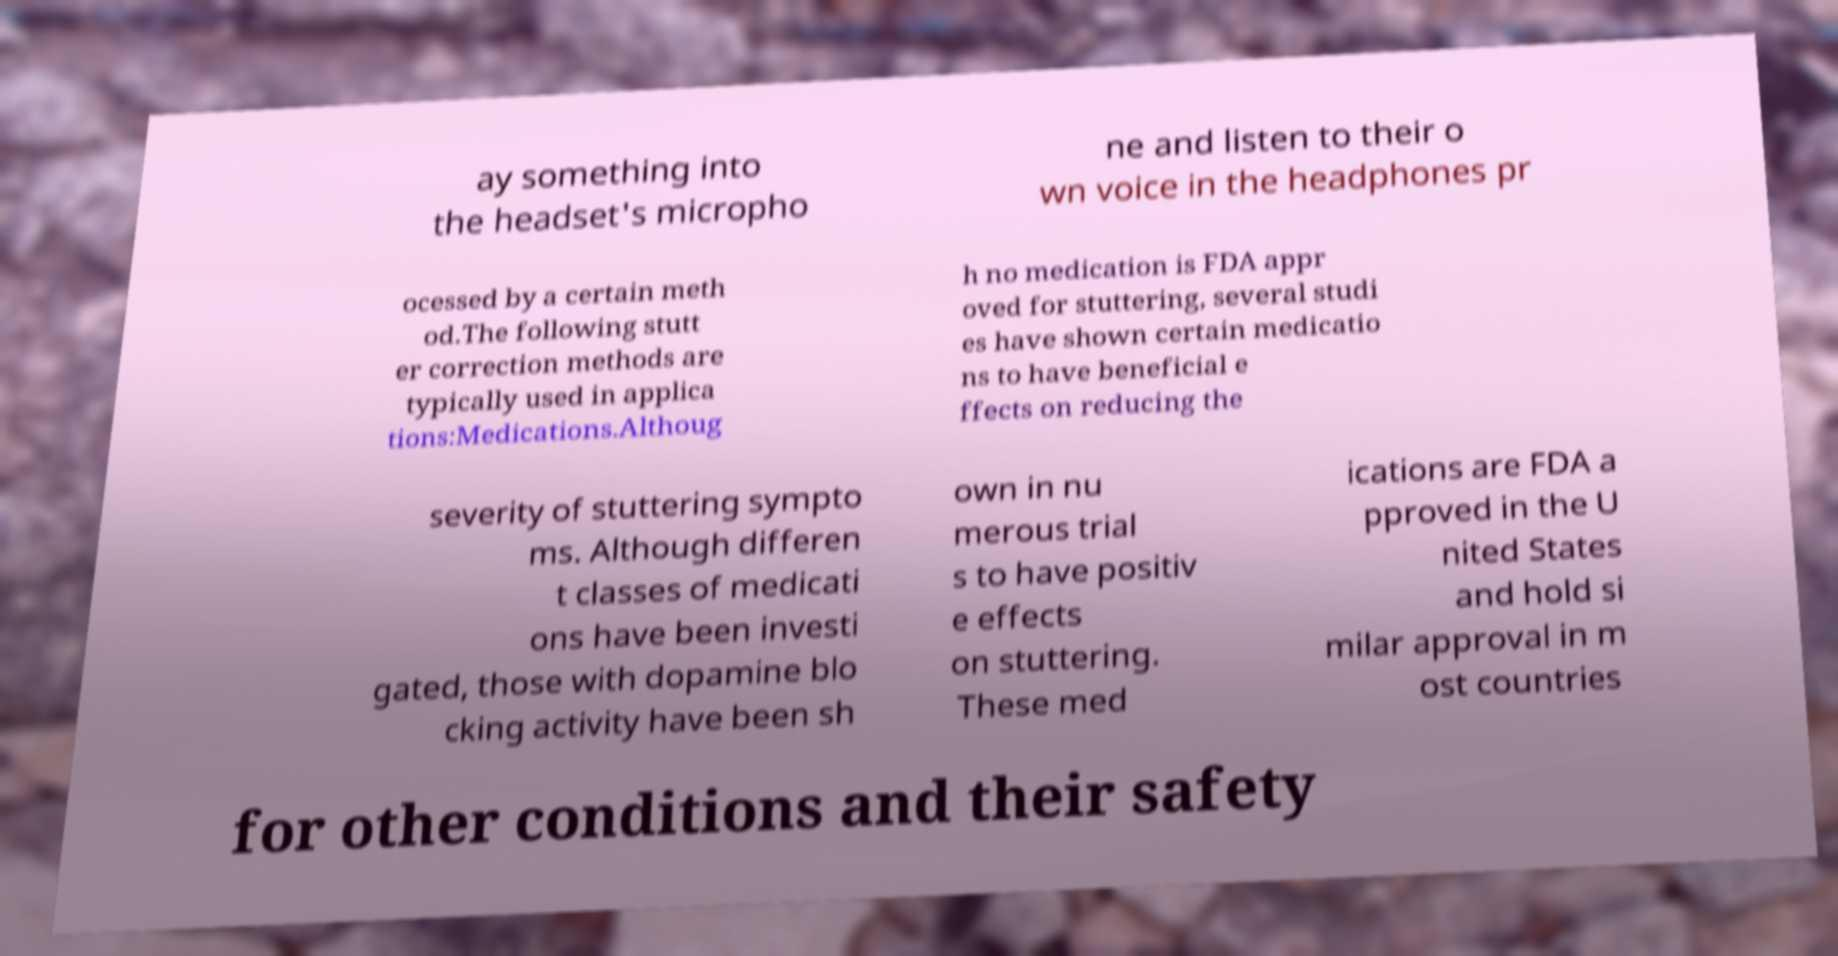What messages or text are displayed in this image? I need them in a readable, typed format. ay something into the headset's micropho ne and listen to their o wn voice in the headphones pr ocessed by a certain meth od.The following stutt er correction methods are typically used in applica tions:Medications.Althoug h no medication is FDA appr oved for stuttering, several studi es have shown certain medicatio ns to have beneficial e ffects on reducing the severity of stuttering sympto ms. Although differen t classes of medicati ons have been investi gated, those with dopamine blo cking activity have been sh own in nu merous trial s to have positiv e effects on stuttering. These med ications are FDA a pproved in the U nited States and hold si milar approval in m ost countries for other conditions and their safety 